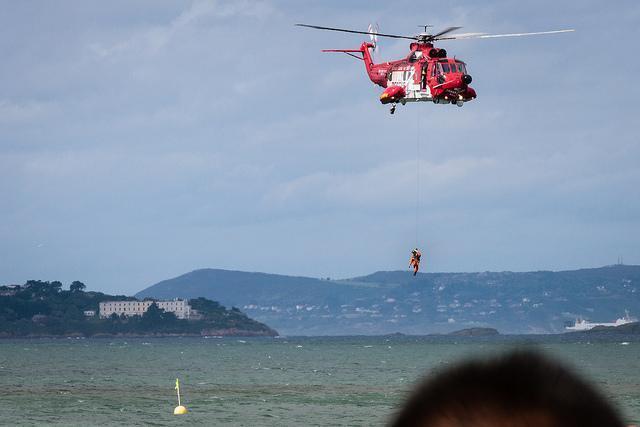How many people are there?
Give a very brief answer. 1. How many clocks are on the tower?
Give a very brief answer. 0. 